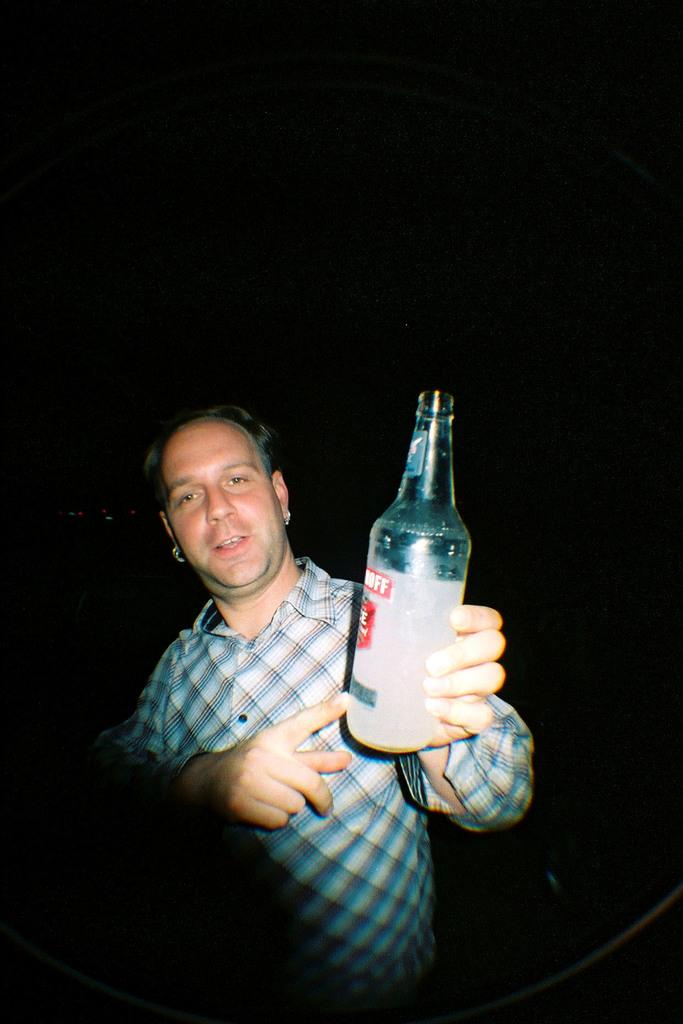What is present in the image? There is a man in the image. What is the man holding in his hand? The man is holding a bottle in his hand. Is the man wearing a ring on his finger in the image? There is no mention of a ring in the provided facts, so it cannot be determined if the man is wearing a ring in the image. 